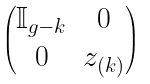Convert formula to latex. <formula><loc_0><loc_0><loc_500><loc_500>\begin{pmatrix} \mathbb { I } _ { g - k } & 0 \\ 0 & z _ { ( k ) } \end{pmatrix}</formula> 